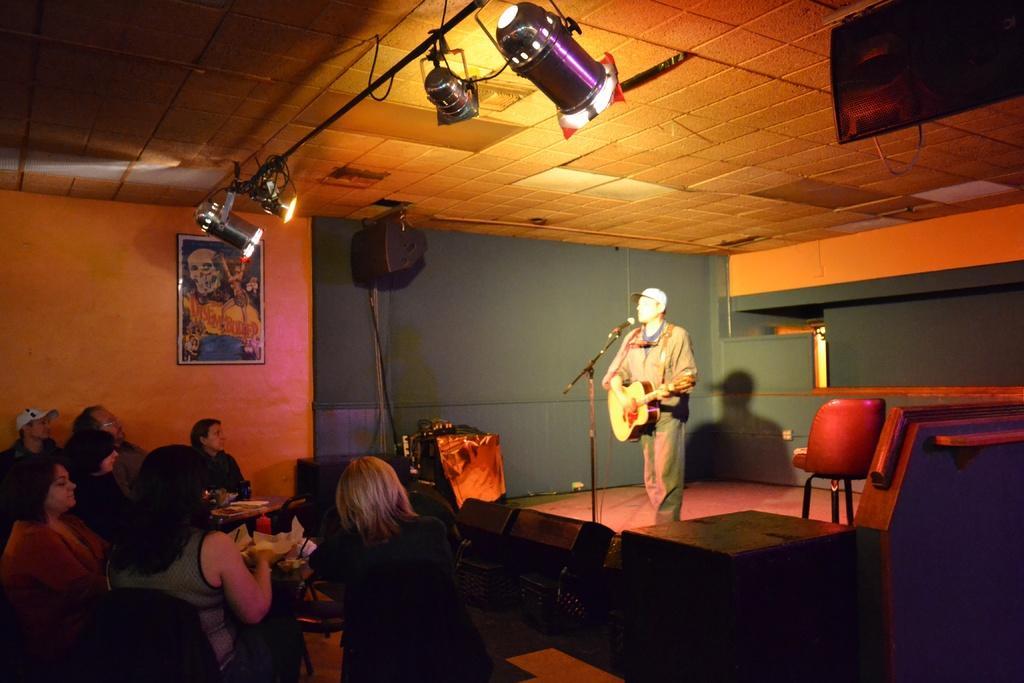In one or two sentences, can you explain what this image depicts? In the picture we can see a man standing and holding a guitar near the microphone on the stage. Under the stage there are some people sitting on the chairs and having a food. On the ceiling we can see lights and to the wall there are photo frames. 